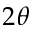<formula> <loc_0><loc_0><loc_500><loc_500>2 \theta</formula> 